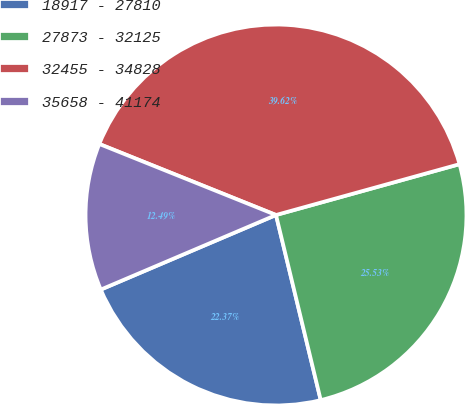<chart> <loc_0><loc_0><loc_500><loc_500><pie_chart><fcel>18917 - 27810<fcel>27873 - 32125<fcel>32455 - 34828<fcel>35658 - 41174<nl><fcel>22.37%<fcel>25.53%<fcel>39.62%<fcel>12.49%<nl></chart> 